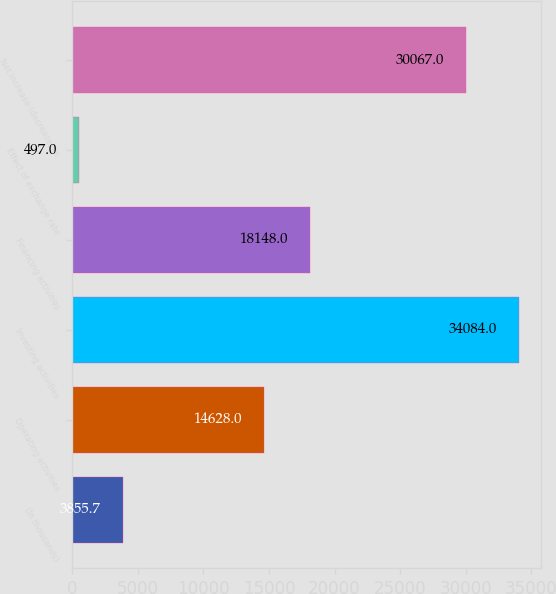Convert chart. <chart><loc_0><loc_0><loc_500><loc_500><bar_chart><fcel>(In thousands)<fcel>Operating activities<fcel>Investing activities<fcel>Financing activities<fcel>Effect of exchange rate<fcel>Net increase (decrease) in<nl><fcel>3855.7<fcel>14628<fcel>34084<fcel>18148<fcel>497<fcel>30067<nl></chart> 